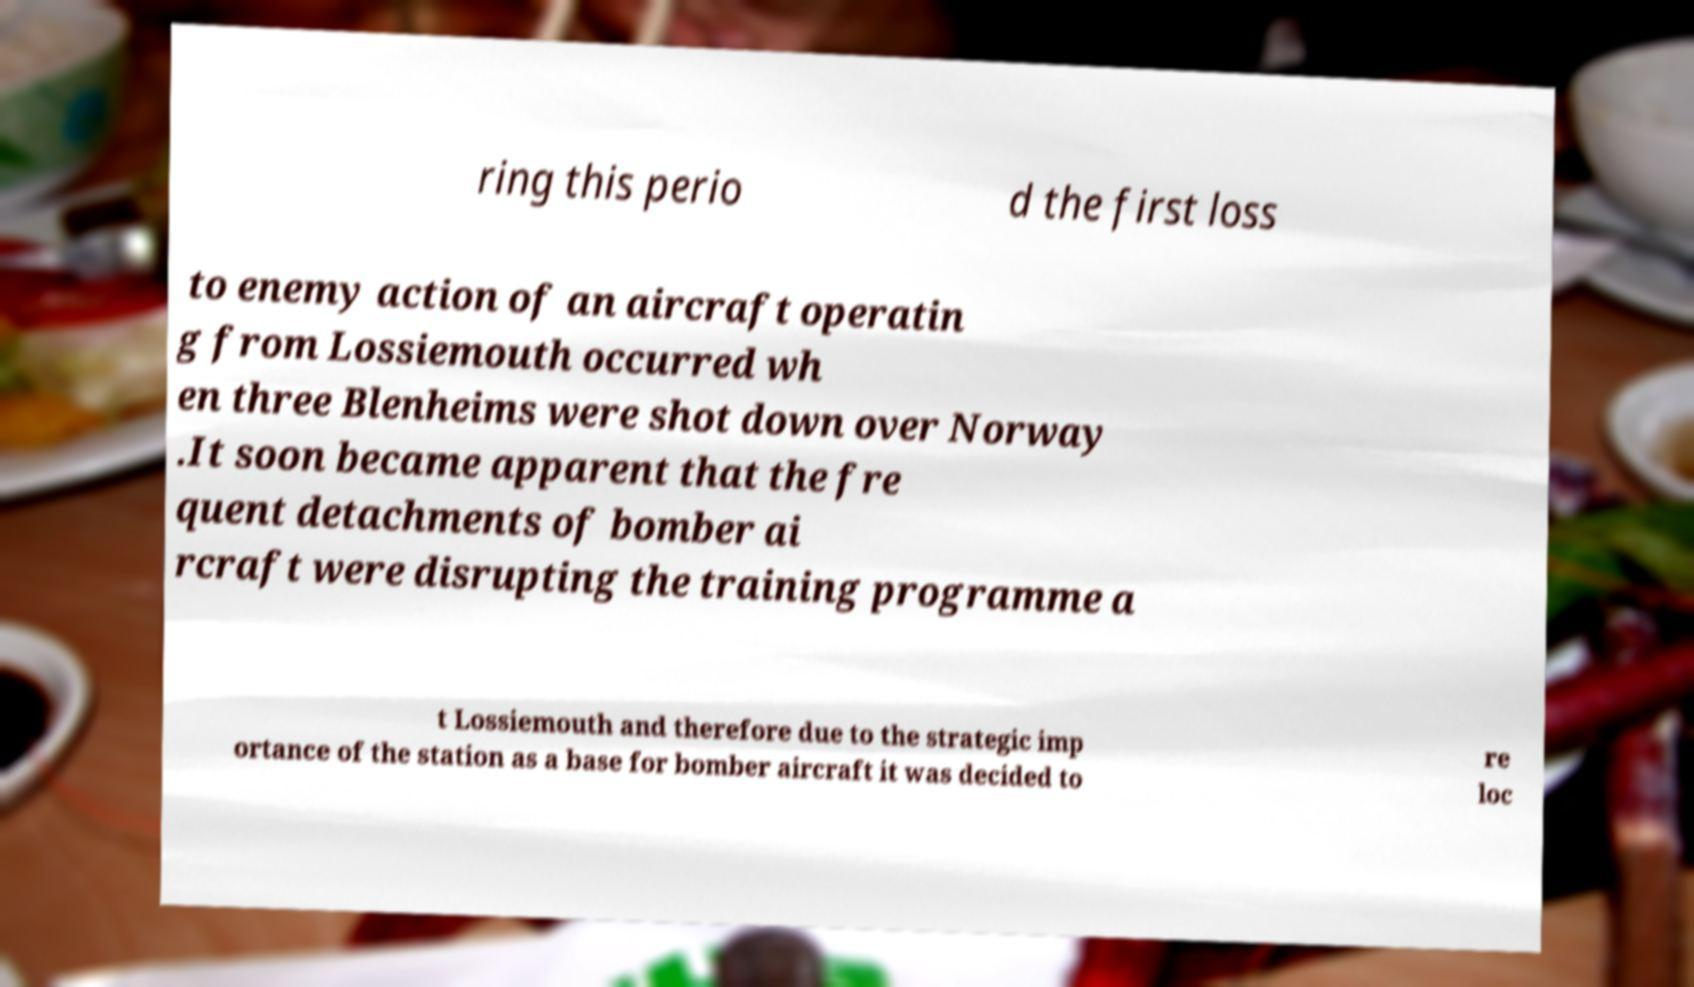Could you extract and type out the text from this image? ring this perio d the first loss to enemy action of an aircraft operatin g from Lossiemouth occurred wh en three Blenheims were shot down over Norway .It soon became apparent that the fre quent detachments of bomber ai rcraft were disrupting the training programme a t Lossiemouth and therefore due to the strategic imp ortance of the station as a base for bomber aircraft it was decided to re loc 